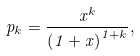Convert formula to latex. <formula><loc_0><loc_0><loc_500><loc_500>p _ { k } = \frac { x ^ { k } } { \left ( 1 + x \right ) ^ { 1 + k } } ,</formula> 